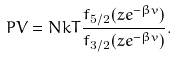Convert formula to latex. <formula><loc_0><loc_0><loc_500><loc_500>P V = N k T \frac { f _ { 5 / 2 } ( z e ^ { - \beta v } ) } { f _ { 3 / 2 } ( z e ^ { - \beta v } ) } .</formula> 